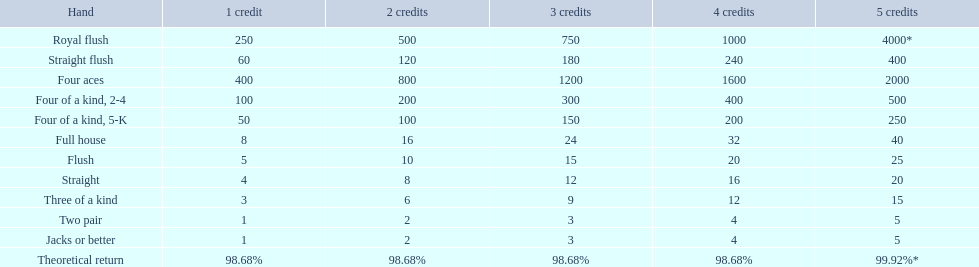What are the hands? Royal flush, Straight flush, Four aces, Four of a kind, 2-4, Four of a kind, 5-K, Full house, Flush, Straight, Three of a kind, Two pair, Jacks or better. Which hand is above? Royal flush. 